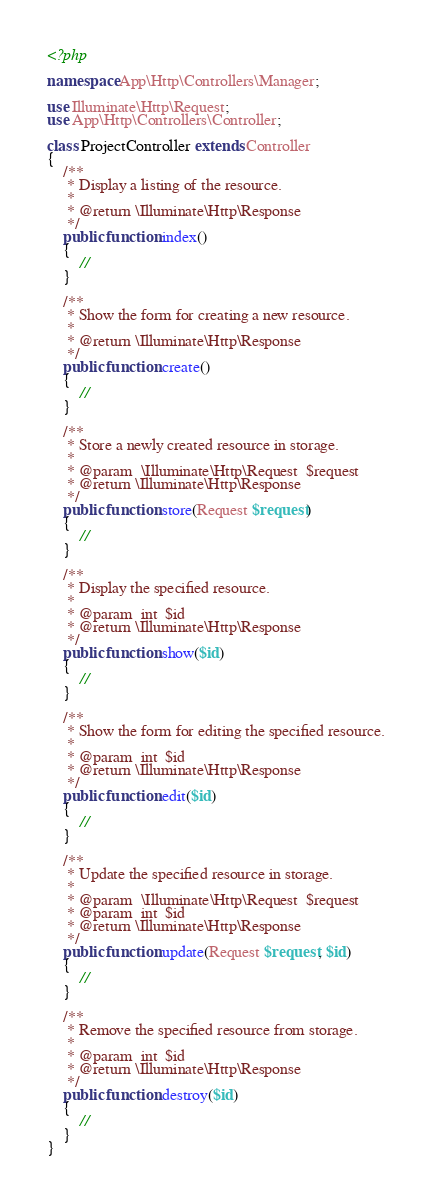Convert code to text. <code><loc_0><loc_0><loc_500><loc_500><_PHP_><?php

namespace App\Http\Controllers\Manager;

use Illuminate\Http\Request;
use App\Http\Controllers\Controller;

class ProjectController extends Controller
{
    /**
     * Display a listing of the resource.
     *
     * @return \Illuminate\Http\Response
     */
    public function index()
    {
        //
    }

    /**
     * Show the form for creating a new resource.
     *
     * @return \Illuminate\Http\Response
     */
    public function create()
    {
        //
    }

    /**
     * Store a newly created resource in storage.
     *
     * @param  \Illuminate\Http\Request  $request
     * @return \Illuminate\Http\Response
     */
    public function store(Request $request)
    {
        //
    }

    /**
     * Display the specified resource.
     *
     * @param  int  $id
     * @return \Illuminate\Http\Response
     */
    public function show($id)
    {
        //
    }

    /**
     * Show the form for editing the specified resource.
     *
     * @param  int  $id
     * @return \Illuminate\Http\Response
     */
    public function edit($id)
    {
        //
    }

    /**
     * Update the specified resource in storage.
     *
     * @param  \Illuminate\Http\Request  $request
     * @param  int  $id
     * @return \Illuminate\Http\Response
     */
    public function update(Request $request, $id)
    {
        //
    }

    /**
     * Remove the specified resource from storage.
     *
     * @param  int  $id
     * @return \Illuminate\Http\Response
     */
    public function destroy($id)
    {
        //
    }
}
</code> 